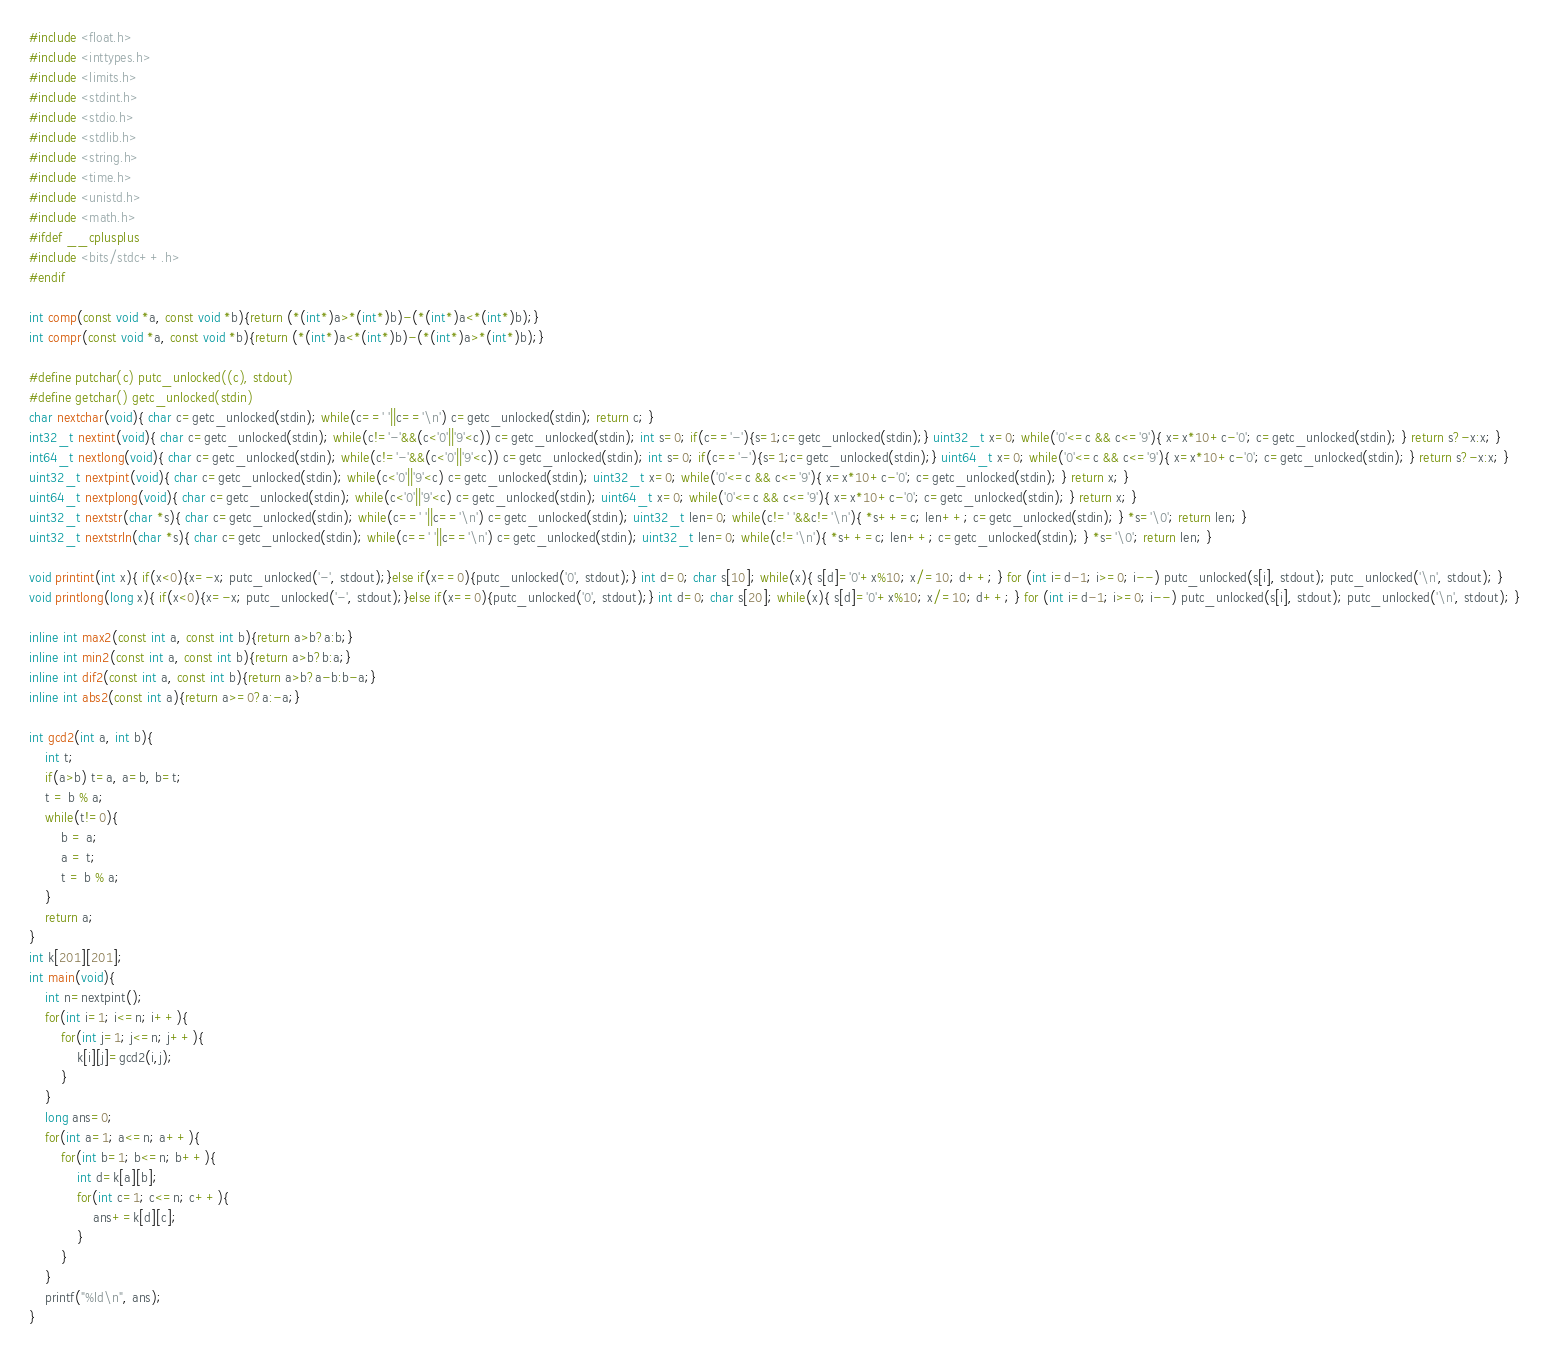Convert code to text. <code><loc_0><loc_0><loc_500><loc_500><_C_>#include <float.h>
#include <inttypes.h>
#include <limits.h>
#include <stdint.h>
#include <stdio.h>
#include <stdlib.h>
#include <string.h>
#include <time.h>
#include <unistd.h>
#include <math.h>
#ifdef __cplusplus
#include <bits/stdc++.h>
#endif

int comp(const void *a, const void *b){return (*(int*)a>*(int*)b)-(*(int*)a<*(int*)b);}
int compr(const void *a, const void *b){return (*(int*)a<*(int*)b)-(*(int*)a>*(int*)b);}

#define putchar(c) putc_unlocked((c), stdout)
#define getchar() getc_unlocked(stdin)
char nextchar(void){ char c=getc_unlocked(stdin); while(c==' '||c=='\n') c=getc_unlocked(stdin); return c; }
int32_t nextint(void){ char c=getc_unlocked(stdin); while(c!='-'&&(c<'0'||'9'<c)) c=getc_unlocked(stdin); int s=0; if(c=='-'){s=1;c=getc_unlocked(stdin);} uint32_t x=0; while('0'<=c && c<='9'){ x=x*10+c-'0'; c=getc_unlocked(stdin); } return s?-x:x; }
int64_t nextlong(void){ char c=getc_unlocked(stdin); while(c!='-'&&(c<'0'||'9'<c)) c=getc_unlocked(stdin); int s=0; if(c=='-'){s=1;c=getc_unlocked(stdin);} uint64_t x=0; while('0'<=c && c<='9'){ x=x*10+c-'0'; c=getc_unlocked(stdin); } return s?-x:x; }
uint32_t nextpint(void){ char c=getc_unlocked(stdin); while(c<'0'||'9'<c) c=getc_unlocked(stdin); uint32_t x=0; while('0'<=c && c<='9'){ x=x*10+c-'0'; c=getc_unlocked(stdin); } return x; }
uint64_t nextplong(void){ char c=getc_unlocked(stdin); while(c<'0'||'9'<c) c=getc_unlocked(stdin); uint64_t x=0; while('0'<=c && c<='9'){ x=x*10+c-'0'; c=getc_unlocked(stdin); } return x; }
uint32_t nextstr(char *s){ char c=getc_unlocked(stdin); while(c==' '||c=='\n') c=getc_unlocked(stdin); uint32_t len=0; while(c!=' '&&c!='\n'){ *s++=c; len++; c=getc_unlocked(stdin); } *s='\0'; return len; }
uint32_t nextstrln(char *s){ char c=getc_unlocked(stdin); while(c==' '||c=='\n') c=getc_unlocked(stdin); uint32_t len=0; while(c!='\n'){ *s++=c; len++; c=getc_unlocked(stdin); } *s='\0'; return len; }

void printint(int x){ if(x<0){x=-x; putc_unlocked('-', stdout);}else if(x==0){putc_unlocked('0', stdout);} int d=0; char s[10]; while(x){ s[d]='0'+x%10; x/=10; d++; } for (int i=d-1; i>=0; i--) putc_unlocked(s[i], stdout); putc_unlocked('\n', stdout); }
void printlong(long x){ if(x<0){x=-x; putc_unlocked('-', stdout);}else if(x==0){putc_unlocked('0', stdout);} int d=0; char s[20]; while(x){ s[d]='0'+x%10; x/=10; d++; } for (int i=d-1; i>=0; i--) putc_unlocked(s[i], stdout); putc_unlocked('\n', stdout); }

inline int max2(const int a, const int b){return a>b?a:b;}
inline int min2(const int a, const int b){return a>b?b:a;}
inline int dif2(const int a, const int b){return a>b?a-b:b-a;}
inline int abs2(const int a){return a>=0?a:-a;}

int gcd2(int a, int b){
	int t;
	if(a>b) t=a, a=b, b=t;
	t = b % a;
	while(t!=0){
		b = a;
		a = t;
		t = b % a;
	}
	return a;
}
int k[201][201];
int main(void){
	int n=nextpint();
	for(int i=1; i<=n; i++){
		for(int j=1; j<=n; j++){
			k[i][j]=gcd2(i,j);
		}
	}
	long ans=0;
	for(int a=1; a<=n; a++){
		for(int b=1; b<=n; b++){
			int d=k[a][b];
			for(int c=1; c<=n; c++){
				ans+=k[d][c];
			}
		}
	}
	printf("%ld\n", ans);
}
</code> 